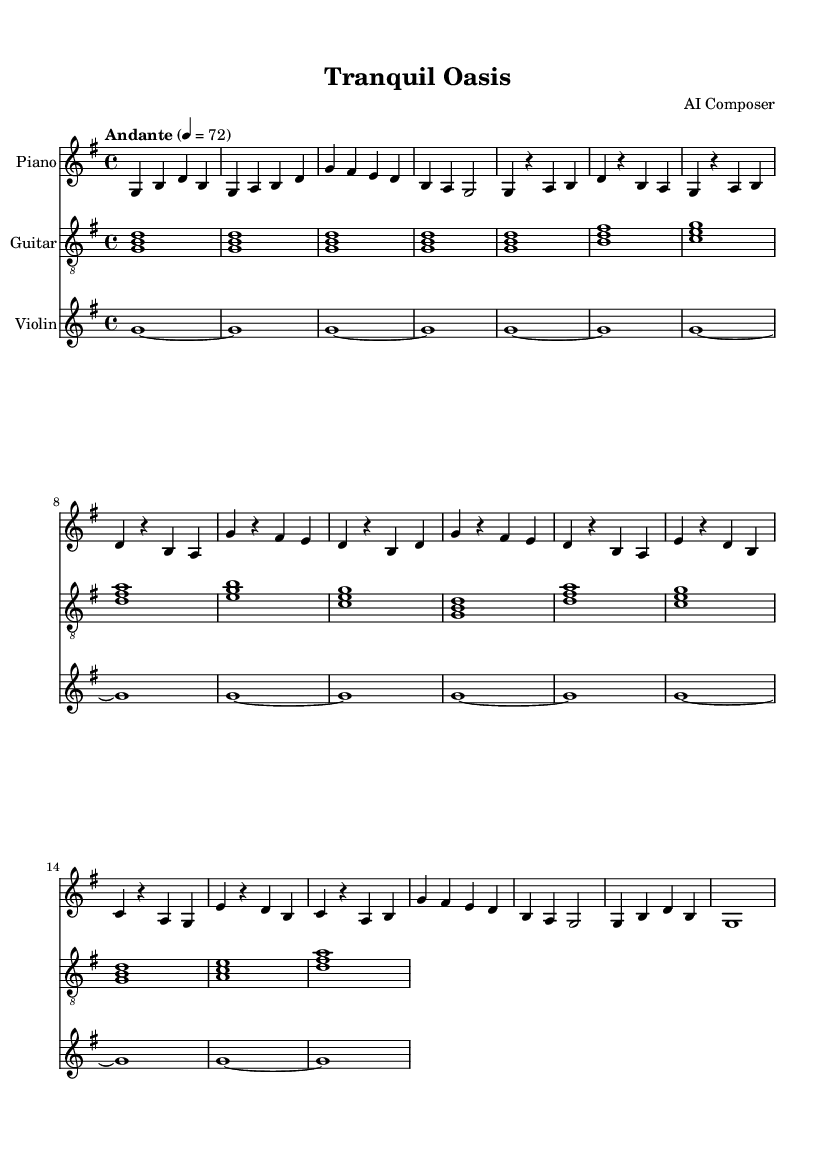what is the key signature of this music? The key signature is shown after the clef symbol at the beginning of the staff. In this score, there are no sharps or flats indicated, which means it is in G major, which has one sharp.
Answer: G major what is the time signature of this music? The time signature is found at the beginning of the score, right after the key signature. Here, it shows 4/4, meaning there are four beats in each measure and the quarter note gets one beat.
Answer: 4/4 what is the tempo marking of this music? The tempo marking is indicated at the beginning, where it states "Andante" with a number 4 = 72. "Andante" indicates a moderately slow tempo.
Answer: Andante how many measures are there in the piano part? By counting the measures in the piano section, we can see there are a total of eight measures present in the provided music excerpt.
Answer: Eight what instruments are featured in this piece? The instruments can be identified from the labels on each staff in the score. There are three different instruments listed: Piano, Guitar, and Violin.
Answer: Piano, Guitar, Violin which instrument plays the melody primarily? By analyzing the provided parts, we can see that the piano has the most prominent melodic lines, with flowing notes and movement in its part, indicating it carries the melody.
Answer: Piano what is the overall mood conveyed by the piece? The piece is titled "Tranquil Oasis" and the choice of instruments (piano, guitar, violin) along with the calm tempo and melodic structure suggests a serene and relaxing mood intended for stress relief.
Answer: Relaxing 